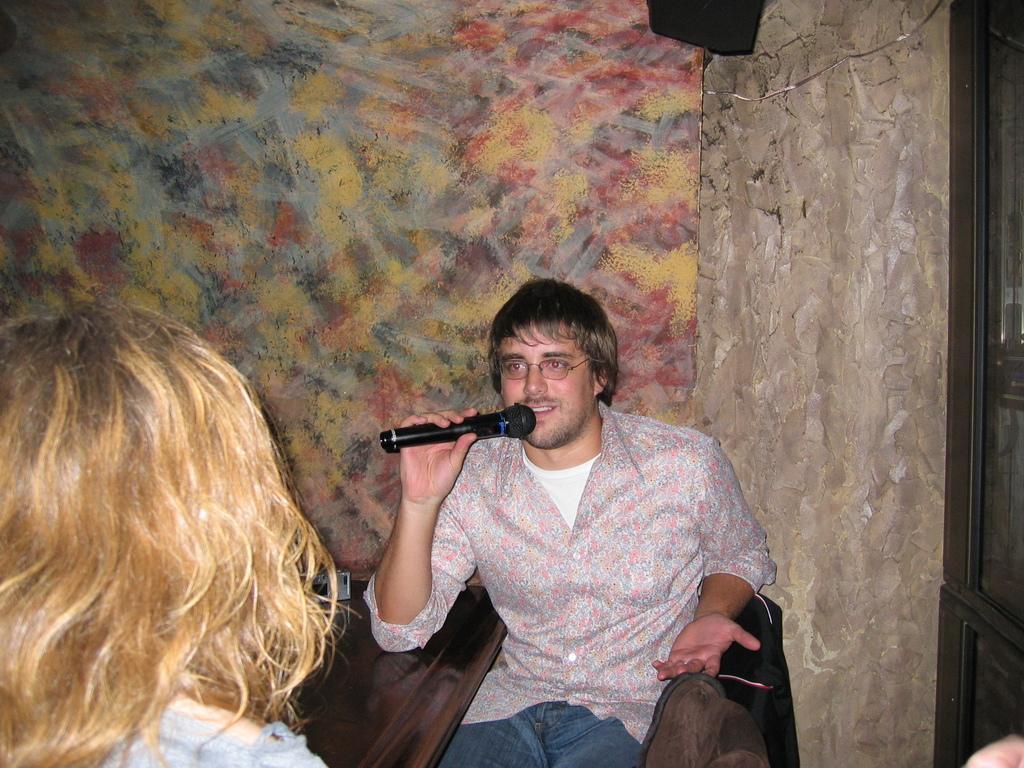Describe this image in one or two sentences. In this picture we can see a man is sitting on a chair and he is holding a microphone. On the left side of the man there is another person. On the right side of the man, it looks like a door. Behind the man, there are some objects and a wall. 